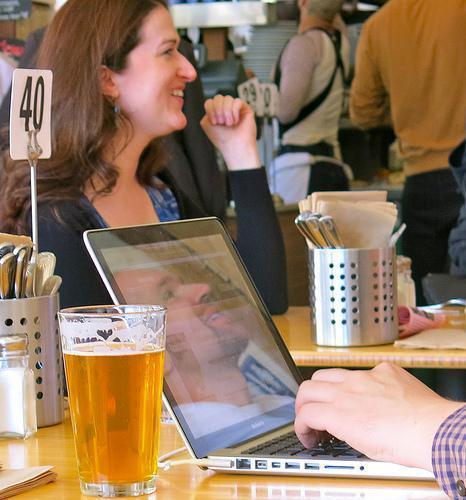How many women are sitting?
Give a very brief answer. 1. 